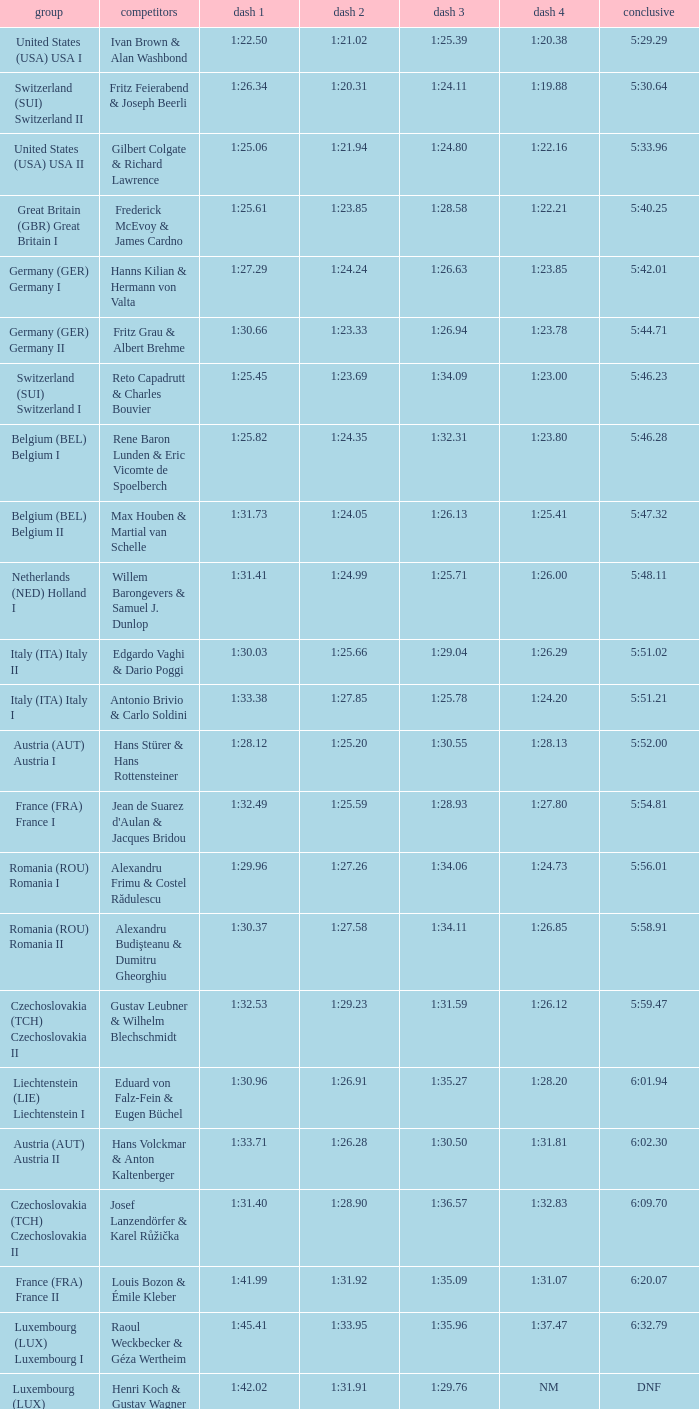Which Run 4 has a Run 3 of 1:26.63? 1:23.85. 